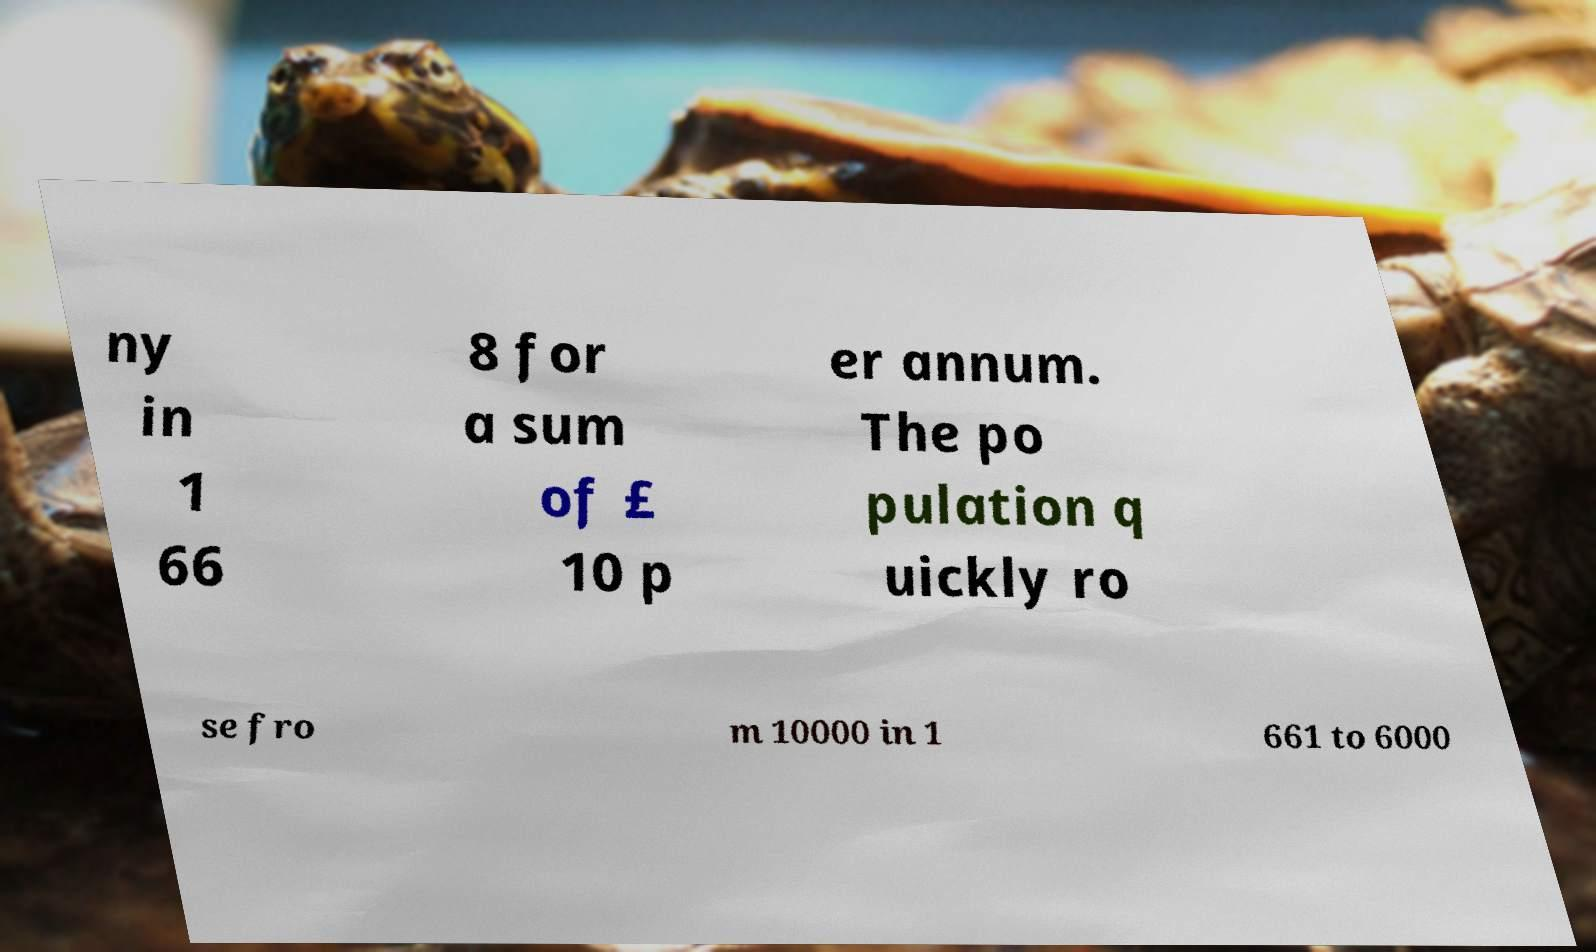Can you accurately transcribe the text from the provided image for me? ny in 1 66 8 for a sum of £ 10 p er annum. The po pulation q uickly ro se fro m 10000 in 1 661 to 6000 